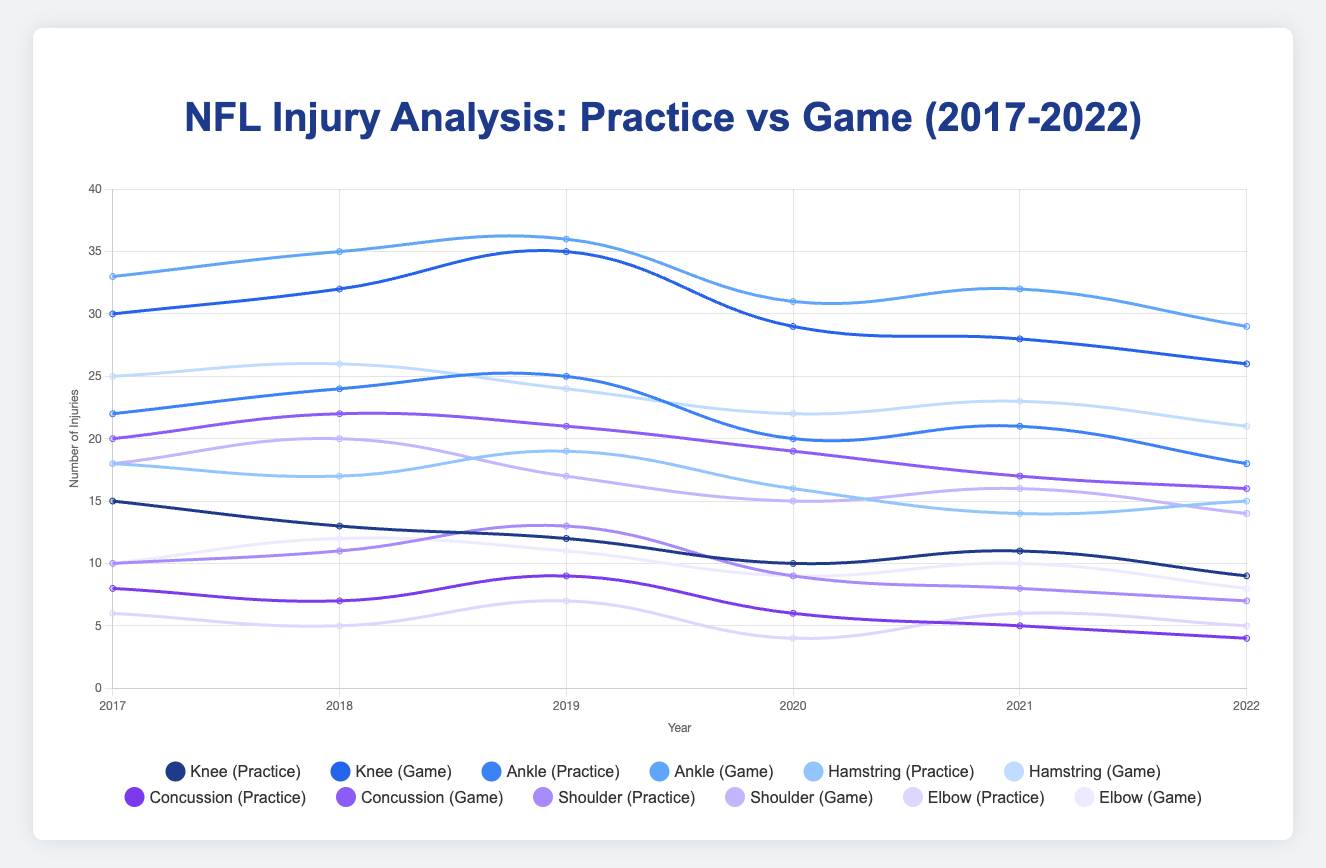What’s the overall trend for knee injuries in practices between 2017 and 2022? To determine the trend, observe the line representing knee injuries during practices over the years. Starting from 2017 with 15 injuries, the number decreases overall until 2022, which sees 9 injuries. This indicates a downward trend.
Answer: Downward trend How do the concussion injuries in games compare to practices in 2019? For 2019, compare the data points for concussion injuries: 9 during practices and 21 during games. The number of concussions in games is higher.
Answer: Higher in games Which year had the fewest elbow injuries in practices? Examine the data for elbow injuries across the years. The lowest value is 4 in 2020.
Answer: 2020 Between ankle and knee injuries, which was more frequent during games in 2021? Compare the data points for 2021: Ankle injuries (32) and knee injuries (28). Ankle injuries were more frequent.
Answer: Ankle injuries What's the percentage change in shoulder injuries during games from 2017 to 2022? Calculate the percentage change: (14 - 18) / 18 * 100 = -22.22%. There’s a 22.22% decrease.
Answer: -22.22% In which year did hamstring injuries during practices see the highest occurrence? Identify the maximum value in the practice injuries data for hamstrings, which is 19 in the year 2019.
Answer: 2019 Is there a visible difference in the trend of shoulder injuries between practice and game contexts over the given years? Observe the lines for shoulder injuries in practices and games. Both trends generally decrease, but shoulder injuries in games start higher and decrease more steeply compared to practices.
Answer: Yes By how many injuries did ankle injuries in practices decrease between 2018 and 2019? Calculate the difference: 25 (2019) - 24 (2018) = 1. There was an increase of 1, not a decrease.
Answer: Increase of 1 Which type of injury had the highest increase in game injuries from 2017 to 2018? Compare the increase for each injury type from 2017 to 2018. The highest increase is for concussions, moving from 20 to 22, which is an increase of 2.
Answer: Concussion injuries What is the average number of practice injuries for shoulder injuries between 2017 and 2022? Calculate the average: (10 + 11 + 13 + 9 + 8 + 7) / 6 = 9.67.
Answer: 9.67 